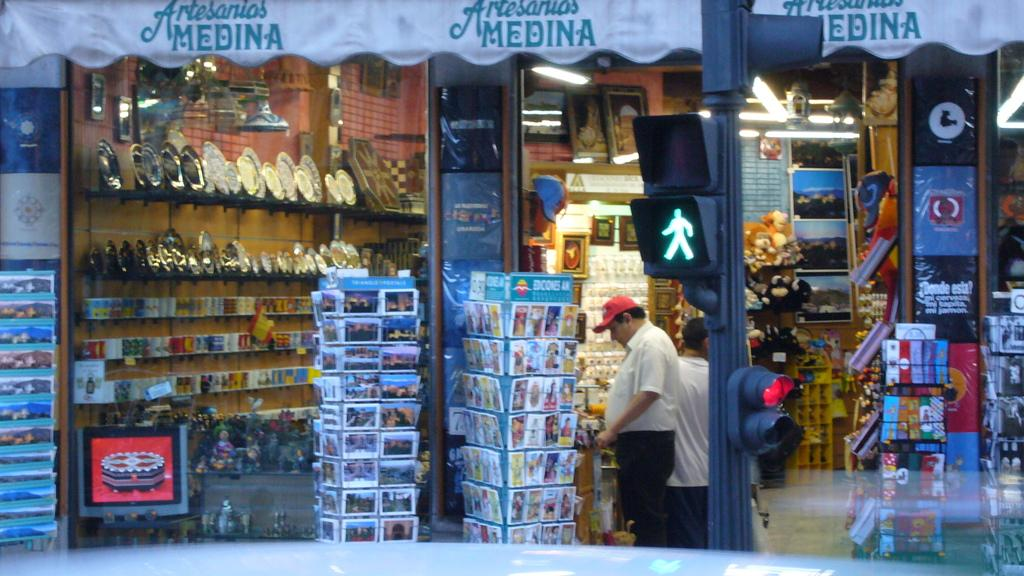Provide a one-sentence caption for the provided image. A few shoppers, one wearing a red hat, at Artesanios Medina. 